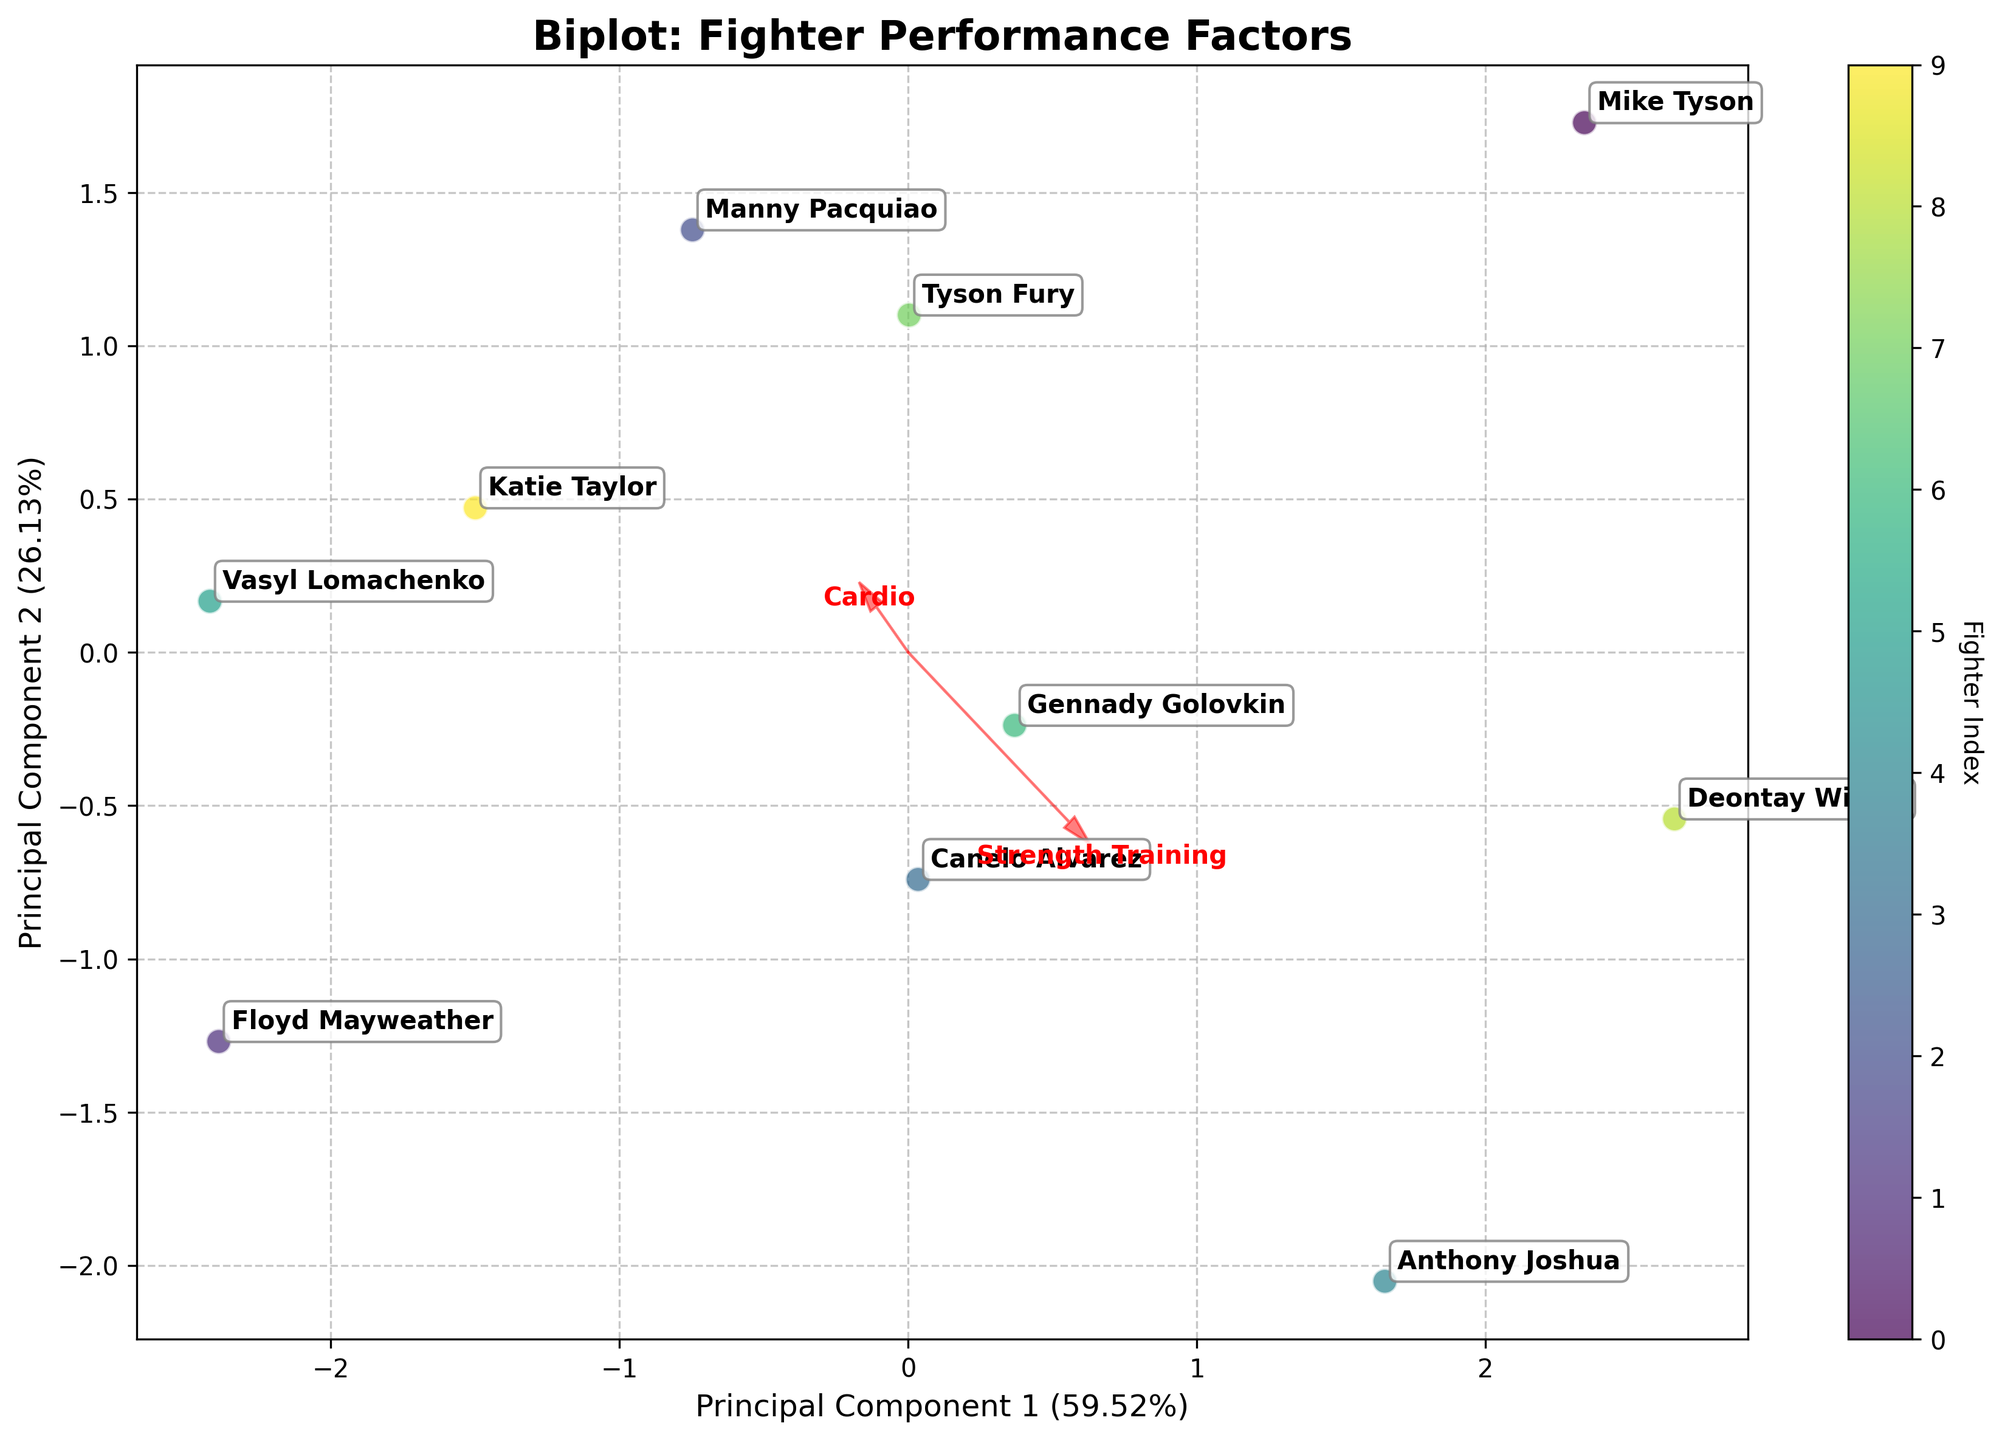What is the main purpose of this Biplot? The biplot aims to visually represent the relationship between different training regimen components and their impact on fighter performance using Principal Component Analysis (PCA). It helps identify how each fighter and feature contribute to the variance in the data.
Answer: To show the relationship between training components and fighter performance using PCA How are the fighters represented in the Biplot? Fighters are represented as points on the plot, each labeled with the fighter's name for identification.
Answer: As points with names labeled Which fighters have a strong emphasis on Cardio and Technique Drills? Fighters that are positioned in the direction of the vectors for Cardio and Technique Drills have strong emphasis on those components. From the plot, Floyd Mayweather and Vasyl Lomachenko are closest to these vectors.
Answer: Floyd Mayweather and Vasyl Lomachenko Which training component has the highest influence on Principal Component 1? By looking at the vectors projected onto Principal Component 1, the training component with the longest vector along this axis shows the highest influence. In this case, it appears to be Strength Training.
Answer: Strength Training Between Mike Tyson and Deontay Wilder, who focuses more on Strength Training? By comparing the positions of these fighters along the direction of the Strength Training vector, Mike Tyson is positioned more in the direction of the Strength Training vector, indicating a stronger emphasis on it.
Answer: Mike Tyson Which principal component explains more variance in the data? The axis labels show the variance explained by each principal component. Principal Component 1 explains a higher percentage of the variance than Principal Component 2.
Answer: Principal Component 1 What do the red arrows in the biplot represent? The red arrows represent the direction and magnitude of each training regimen component in the transformed PCA space, showing how each component contributes to the principal components.
Answer: Training regimen components' directions and magnitudes How do Anthony Joshua and Tyson Fury compare in terms of their training regimen? By looking at the positions of Anthony Joshua and Tyson Fury in the plot, Anthony Joshua is more aligned with Strength Training, while Tyson Fury is more aligned with Cardio and Sparring.
Answer: Anthony Joshua has more Strength Training focus; Tyson Fury focuses on Cardio and Sparring Which training component has the least influence on both principal components? The training component with the shortest vector has the least influence on the principal components. In this biplot, it is Nutrition.
Answer: Nutrition Do any fighters have a balanced emphasis across all training components? Fighters that are positioned towards the center of the plot are likely to have a balanced emphasis across all training components. Canelo Alvarez appears to be close to the center, indicating a balanced training regimen.
Answer: Canelo Alvarez 